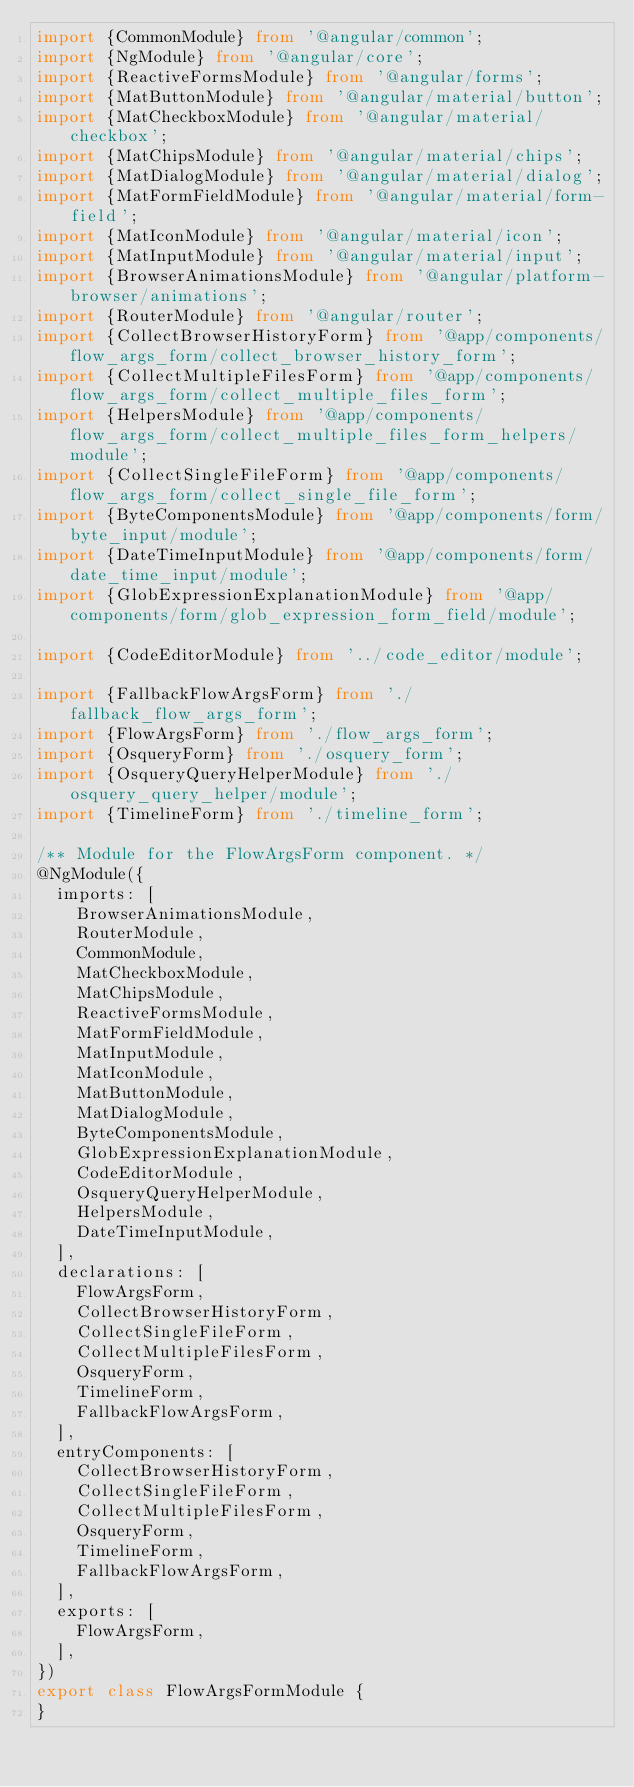<code> <loc_0><loc_0><loc_500><loc_500><_TypeScript_>import {CommonModule} from '@angular/common';
import {NgModule} from '@angular/core';
import {ReactiveFormsModule} from '@angular/forms';
import {MatButtonModule} from '@angular/material/button';
import {MatCheckboxModule} from '@angular/material/checkbox';
import {MatChipsModule} from '@angular/material/chips';
import {MatDialogModule} from '@angular/material/dialog';
import {MatFormFieldModule} from '@angular/material/form-field';
import {MatIconModule} from '@angular/material/icon';
import {MatInputModule} from '@angular/material/input';
import {BrowserAnimationsModule} from '@angular/platform-browser/animations';
import {RouterModule} from '@angular/router';
import {CollectBrowserHistoryForm} from '@app/components/flow_args_form/collect_browser_history_form';
import {CollectMultipleFilesForm} from '@app/components/flow_args_form/collect_multiple_files_form';
import {HelpersModule} from '@app/components/flow_args_form/collect_multiple_files_form_helpers/module';
import {CollectSingleFileForm} from '@app/components/flow_args_form/collect_single_file_form';
import {ByteComponentsModule} from '@app/components/form/byte_input/module';
import {DateTimeInputModule} from '@app/components/form/date_time_input/module';
import {GlobExpressionExplanationModule} from '@app/components/form/glob_expression_form_field/module';

import {CodeEditorModule} from '../code_editor/module';

import {FallbackFlowArgsForm} from './fallback_flow_args_form';
import {FlowArgsForm} from './flow_args_form';
import {OsqueryForm} from './osquery_form';
import {OsqueryQueryHelperModule} from './osquery_query_helper/module';
import {TimelineForm} from './timeline_form';

/** Module for the FlowArgsForm component. */
@NgModule({
  imports: [
    BrowserAnimationsModule,
    RouterModule,
    CommonModule,
    MatCheckboxModule,
    MatChipsModule,
    ReactiveFormsModule,
    MatFormFieldModule,
    MatInputModule,
    MatIconModule,
    MatButtonModule,
    MatDialogModule,
    ByteComponentsModule,
    GlobExpressionExplanationModule,
    CodeEditorModule,
    OsqueryQueryHelperModule,
    HelpersModule,
    DateTimeInputModule,
  ],
  declarations: [
    FlowArgsForm,
    CollectBrowserHistoryForm,
    CollectSingleFileForm,
    CollectMultipleFilesForm,
    OsqueryForm,
    TimelineForm,
    FallbackFlowArgsForm,
  ],
  entryComponents: [
    CollectBrowserHistoryForm,
    CollectSingleFileForm,
    CollectMultipleFilesForm,
    OsqueryForm,
    TimelineForm,
    FallbackFlowArgsForm,
  ],
  exports: [
    FlowArgsForm,
  ],
})
export class FlowArgsFormModule {
}
</code> 